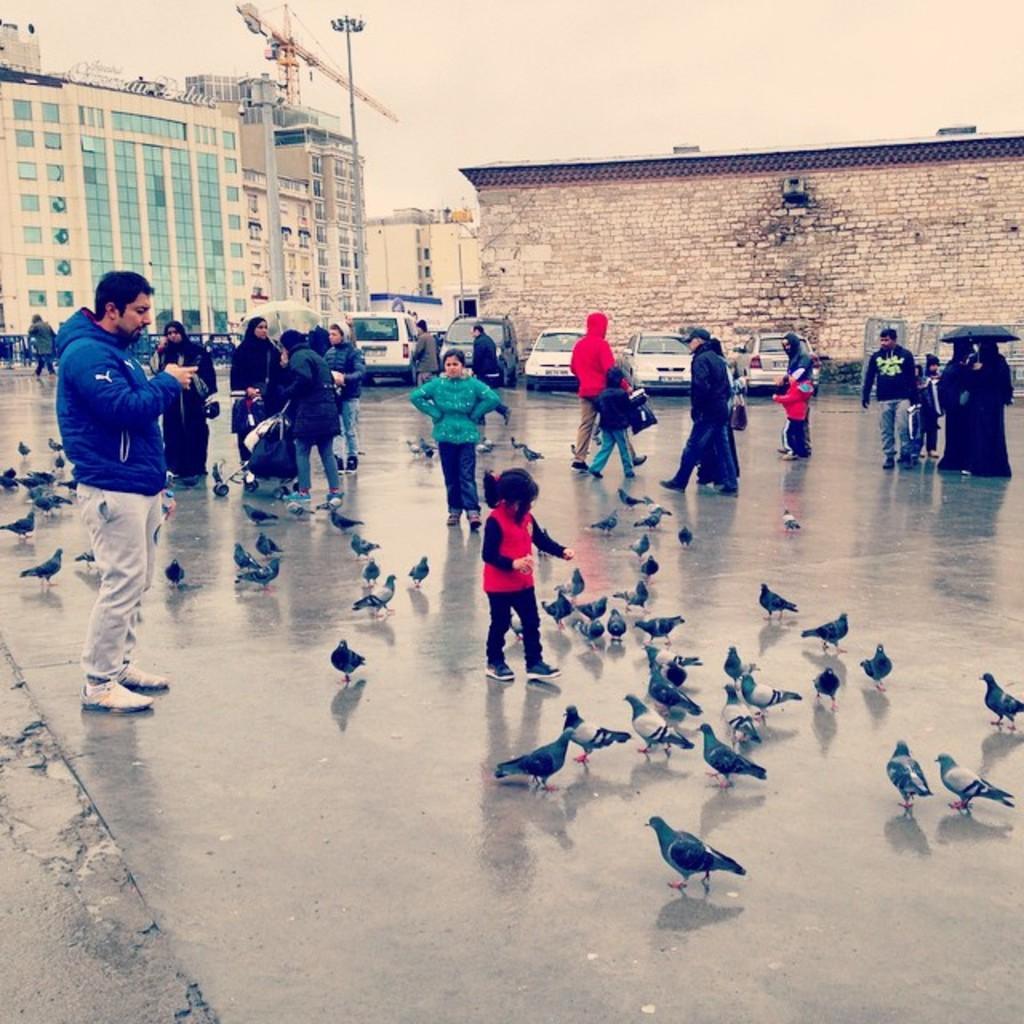In one or two sentences, can you explain what this image depicts? In this picture there is a girl in the center playing with the pigeons which are on the floor. The girl is wearing a red jacket and black trousers. Towards the left, there is a man wearing a blue jacket , cream trousers and holding a mobile. Behind him there is a person holding a baby vehicle. Towards the right there is a person holding an umbrella. In the background there are people, vehicles, buildings etc. On the top there is a sky. 